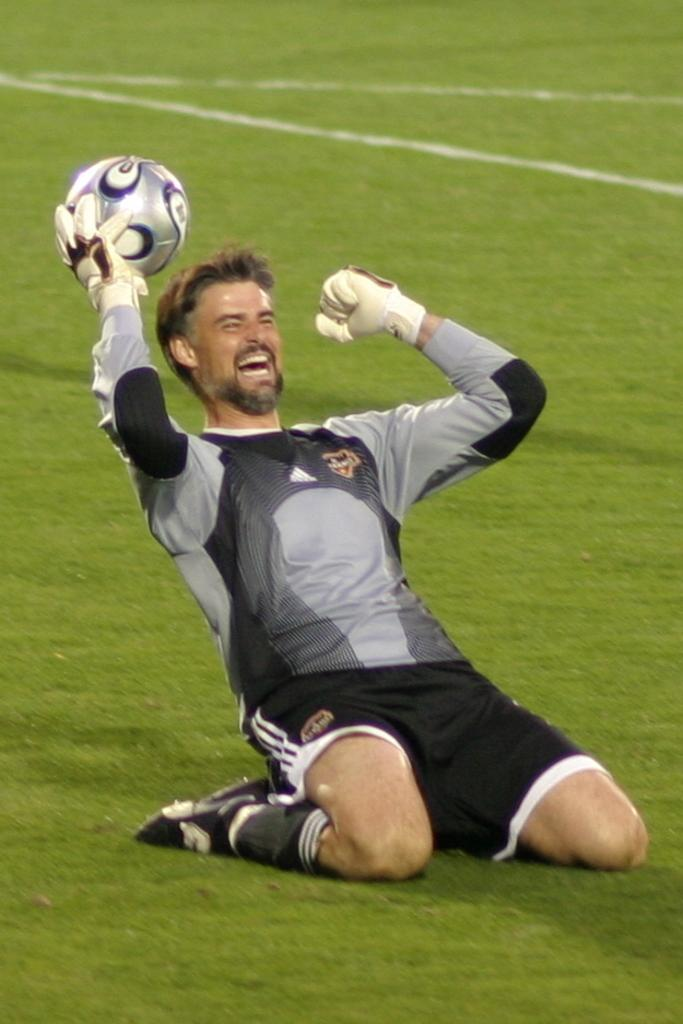What is the man in the image doing? The man is sitting in the grass. What is the man holding in his hand? The man is holding something in his hand. What is the man's facial expression in the image? The man is smiling. What type of coal can be seen in the man's hand in the image? There is no coal present in the image; the man is holding something, but it is not specified as coal. How many mice are visible running around the man in the image? There are no mice present in the image. 